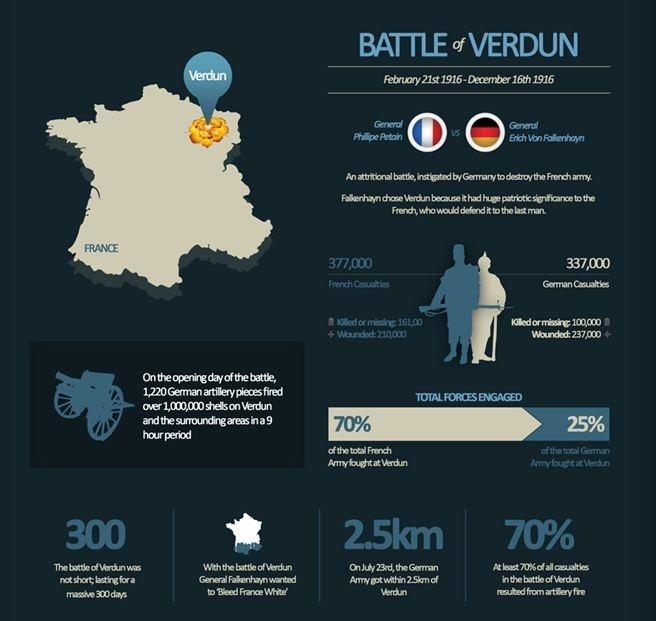Highlight a few significant elements in this photo. During the Battle of Verdun, it is estimated that approximately 100,000 German soldiers died or went missing. During the Battle of Verdun, Erich Von Falkenhayn was the German General. The Battle of Verdun officially came to an end on December 16th, 1916. The Battle of Verdun lasted for 300 days. In the Battle of Verdun, a total of 210,000 French soldiers were wounded. 